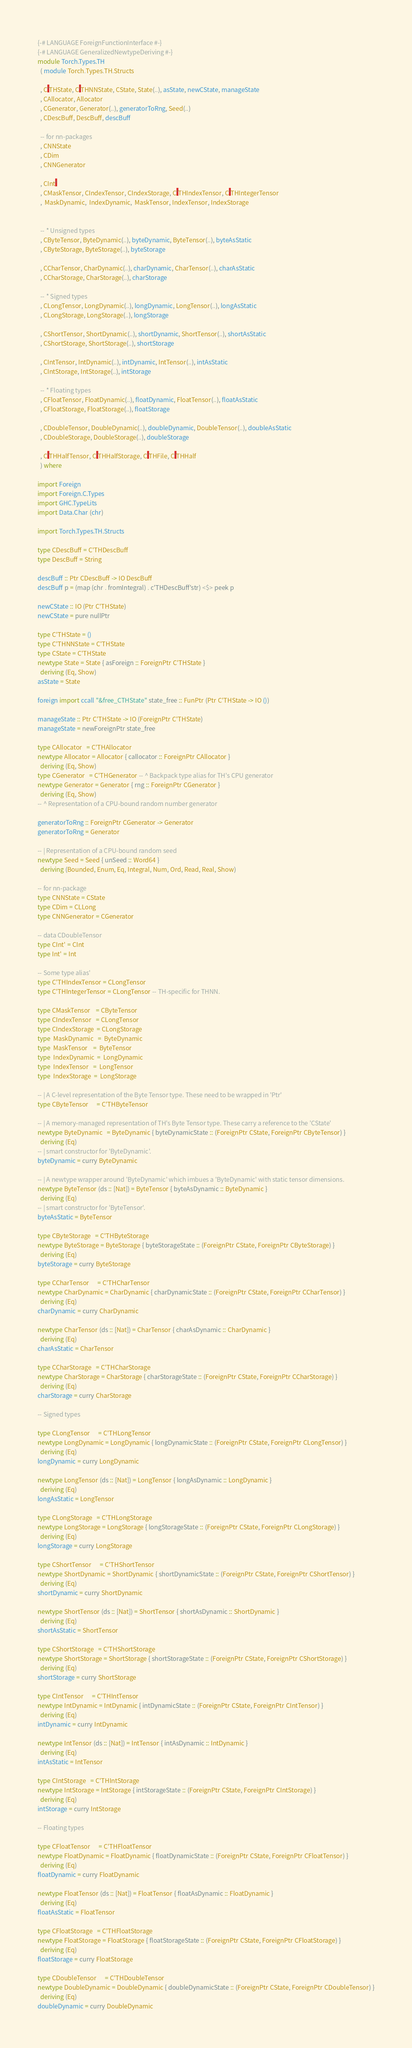<code> <loc_0><loc_0><loc_500><loc_500><_Haskell_>{-# LANGUAGE ForeignFunctionInterface #-}
{-# LANGUAGE GeneralizedNewtypeDeriving #-}
module Torch.Types.TH
  ( module Torch.Types.TH.Structs

  , C'THState, C'THNNState, CState, State(..), asState, newCState, manageState
  , CAllocator, Allocator
  , CGenerator, Generator(..), generatorToRng, Seed(..)
  , CDescBuff, DescBuff, descBuff

  -- for nn-packages
  , CNNState
  , CDim
  , CNNGenerator

  , CInt'
  , CMaskTensor, CIndexTensor, CIndexStorage, C'THIndexTensor, C'THIntegerTensor
  ,  MaskDynamic,  IndexDynamic,  MaskTensor, IndexTensor, IndexStorage


  -- * Unsigned types
  , CByteTensor, ByteDynamic(..), byteDynamic, ByteTensor(..), byteAsStatic
  , CByteStorage, ByteStorage(..), byteStorage

  , CCharTensor, CharDynamic(..), charDynamic, CharTensor(..), charAsStatic
  , CCharStorage, CharStorage(..), charStorage

  -- * Signed types
  , CLongTensor, LongDynamic(..), longDynamic, LongTensor(..), longAsStatic
  , CLongStorage, LongStorage(..), longStorage

  , CShortTensor, ShortDynamic(..), shortDynamic, ShortTensor(..), shortAsStatic
  , CShortStorage, ShortStorage(..), shortStorage

  , CIntTensor, IntDynamic(..), intDynamic, IntTensor(..), intAsStatic
  , CIntStorage, IntStorage(..), intStorage

  -- * Floating types
  , CFloatTensor, FloatDynamic(..), floatDynamic, FloatTensor(..), floatAsStatic
  , CFloatStorage, FloatStorage(..), floatStorage

  , CDoubleTensor, DoubleDynamic(..), doubleDynamic, DoubleTensor(..), doubleAsStatic
  , CDoubleStorage, DoubleStorage(..), doubleStorage

  , C'THHalfTensor, C'THHalfStorage, C'THFile, C'THHalf
  ) where

import Foreign
import Foreign.C.Types
import GHC.TypeLits
import Data.Char (chr)

import Torch.Types.TH.Structs

type CDescBuff = C'THDescBuff
type DescBuff = String

descBuff :: Ptr CDescBuff -> IO DescBuff
descBuff p = (map (chr . fromIntegral) . c'THDescBuff'str) <$> peek p

newCState :: IO (Ptr C'THState)
newCState = pure nullPtr

type C'THState = ()
type C'THNNState = C'THState
type CState = C'THState
newtype State = State { asForeign :: ForeignPtr C'THState }
  deriving (Eq, Show)
asState = State

foreign import ccall "&free_CTHState" state_free :: FunPtr (Ptr C'THState -> IO ())

manageState :: Ptr C'THState -> IO (ForeignPtr C'THState)
manageState = newForeignPtr state_free

type CAllocator   = C'THAllocator
newtype Allocator = Allocator { callocator :: ForeignPtr CAllocator }
  deriving (Eq, Show)
type CGenerator   = C'THGenerator -- ^ Backpack type alias for TH's CPU generator
newtype Generator = Generator { rng :: ForeignPtr CGenerator }
  deriving (Eq, Show)
-- ^ Representation of a CPU-bound random number generator

generatorToRng :: ForeignPtr CGenerator -> Generator
generatorToRng = Generator

-- | Representation of a CPU-bound random seed
newtype Seed = Seed { unSeed :: Word64 }
  deriving (Bounded, Enum, Eq, Integral, Num, Ord, Read, Real, Show)

-- for nn-package
type CNNState = CState
type CDim = CLLong
type CNNGenerator = CGenerator

-- data CDoubleTensor
type CInt' = CInt
type Int' = Int

-- Some type alias'
type C'THIndexTensor = CLongTensor
type C'THIntegerTensor = CLongTensor -- TH-specific for THNN.

type CMaskTensor    = CByteTensor
type CIndexTensor   = CLongTensor
type CIndexStorage  = CLongStorage
type  MaskDynamic   =  ByteDynamic
type  MaskTensor    =  ByteTensor
type  IndexDynamic  =  LongDynamic
type  IndexTensor   =  LongTensor
type  IndexStorage  =  LongStorage

-- | A C-level representation of the Byte Tensor type. These need to be wrapped in 'Ptr'
type CByteTensor      = C'THByteTensor

-- | A memory-managed representation of TH's Byte Tensor type. These carry a reference to the 'CState'
newtype ByteDynamic   = ByteDynamic { byteDynamicState :: (ForeignPtr CState, ForeignPtr CByteTensor) }
  deriving (Eq)
-- | smart constructor for 'ByteDynamic'.
byteDynamic = curry ByteDynamic

-- | A newtype wrapper around 'ByteDynamic' which imbues a 'ByteDynamic' with static tensor dimensions.
newtype ByteTensor (ds :: [Nat]) = ByteTensor { byteAsDynamic :: ByteDynamic }
  deriving (Eq)
-- | smart constructor for 'ByteTensor'.
byteAsStatic = ByteTensor

type CByteStorage   = C'THByteStorage
newtype ByteStorage = ByteStorage { byteStorageState :: (ForeignPtr CState, ForeignPtr CByteStorage) }
  deriving (Eq)
byteStorage = curry ByteStorage

type CCharTensor      = C'THCharTensor
newtype CharDynamic = CharDynamic { charDynamicState :: (ForeignPtr CState, ForeignPtr CCharTensor) }
  deriving (Eq)
charDynamic = curry CharDynamic

newtype CharTensor (ds :: [Nat]) = CharTensor { charAsDynamic :: CharDynamic }
  deriving (Eq)
charAsStatic = CharTensor

type CCharStorage   = C'THCharStorage
newtype CharStorage = CharStorage { charStorageState :: (ForeignPtr CState, ForeignPtr CCharStorage) }
  deriving (Eq)
charStorage = curry CharStorage

-- Signed types

type CLongTensor      = C'THLongTensor
newtype LongDynamic = LongDynamic { longDynamicState :: (ForeignPtr CState, ForeignPtr CLongTensor) }
  deriving (Eq)
longDynamic = curry LongDynamic

newtype LongTensor (ds :: [Nat]) = LongTensor { longAsDynamic :: LongDynamic }
  deriving (Eq)
longAsStatic = LongTensor

type CLongStorage   = C'THLongStorage
newtype LongStorage = LongStorage { longStorageState :: (ForeignPtr CState, ForeignPtr CLongStorage) }
  deriving (Eq)
longStorage = curry LongStorage

type CShortTensor      = C'THShortTensor
newtype ShortDynamic = ShortDynamic { shortDynamicState :: (ForeignPtr CState, ForeignPtr CShortTensor) }
  deriving (Eq)
shortDynamic = curry ShortDynamic

newtype ShortTensor (ds :: [Nat]) = ShortTensor { shortAsDynamic :: ShortDynamic }
  deriving (Eq)
shortAsStatic = ShortTensor

type CShortStorage   = C'THShortStorage
newtype ShortStorage = ShortStorage { shortStorageState :: (ForeignPtr CState, ForeignPtr CShortStorage) }
  deriving (Eq)
shortStorage = curry ShortStorage

type CIntTensor      = C'THIntTensor
newtype IntDynamic = IntDynamic { intDynamicState :: (ForeignPtr CState, ForeignPtr CIntTensor) }
  deriving (Eq)
intDynamic = curry IntDynamic

newtype IntTensor (ds :: [Nat]) = IntTensor { intAsDynamic :: IntDynamic }
  deriving (Eq)
intAsStatic = IntTensor

type CIntStorage   = C'THIntStorage
newtype IntStorage = IntStorage { intStorageState :: (ForeignPtr CState, ForeignPtr CIntStorage) }
  deriving (Eq)
intStorage = curry IntStorage

-- Floating types

type CFloatTensor      = C'THFloatTensor
newtype FloatDynamic = FloatDynamic { floatDynamicState :: (ForeignPtr CState, ForeignPtr CFloatTensor) }
  deriving (Eq)
floatDynamic = curry FloatDynamic

newtype FloatTensor (ds :: [Nat]) = FloatTensor { floatAsDynamic :: FloatDynamic }
  deriving (Eq)
floatAsStatic = FloatTensor

type CFloatStorage   = C'THFloatStorage
newtype FloatStorage = FloatStorage { floatStorageState :: (ForeignPtr CState, ForeignPtr CFloatStorage) }
  deriving (Eq)
floatStorage = curry FloatStorage

type CDoubleTensor      = C'THDoubleTensor
newtype DoubleDynamic = DoubleDynamic { doubleDynamicState :: (ForeignPtr CState, ForeignPtr CDoubleTensor) }
  deriving (Eq)
doubleDynamic = curry DoubleDynamic
</code> 